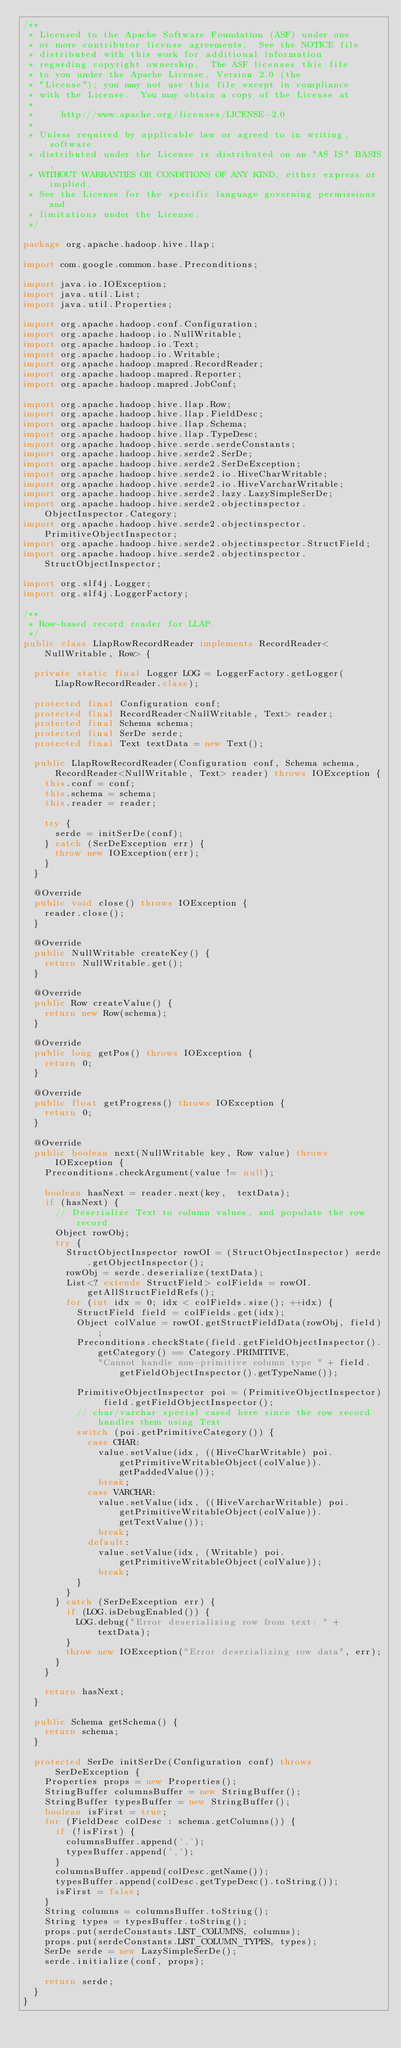<code> <loc_0><loc_0><loc_500><loc_500><_Java_>/**
 * Licensed to the Apache Software Foundation (ASF) under one
 * or more contributor license agreements.  See the NOTICE file
 * distributed with this work for additional information
 * regarding copyright ownership.  The ASF licenses this file
 * to you under the Apache License, Version 2.0 (the
 * "License"); you may not use this file except in compliance
 * with the License.  You may obtain a copy of the License at
 *
 *     http://www.apache.org/licenses/LICENSE-2.0
 *
 * Unless required by applicable law or agreed to in writing, software
 * distributed under the License is distributed on an "AS IS" BASIS,
 * WITHOUT WARRANTIES OR CONDITIONS OF ANY KIND, either express or implied.
 * See the License for the specific language governing permissions and
 * limitations under the License.
 */

package org.apache.hadoop.hive.llap;

import com.google.common.base.Preconditions;

import java.io.IOException;
import java.util.List;
import java.util.Properties;

import org.apache.hadoop.conf.Configuration;
import org.apache.hadoop.io.NullWritable;
import org.apache.hadoop.io.Text;
import org.apache.hadoop.io.Writable;
import org.apache.hadoop.mapred.RecordReader;
import org.apache.hadoop.mapred.Reporter;
import org.apache.hadoop.mapred.JobConf;

import org.apache.hadoop.hive.llap.Row;
import org.apache.hadoop.hive.llap.FieldDesc;
import org.apache.hadoop.hive.llap.Schema;
import org.apache.hadoop.hive.llap.TypeDesc;
import org.apache.hadoop.hive.serde.serdeConstants;
import org.apache.hadoop.hive.serde2.SerDe;
import org.apache.hadoop.hive.serde2.SerDeException;
import org.apache.hadoop.hive.serde2.io.HiveCharWritable;
import org.apache.hadoop.hive.serde2.io.HiveVarcharWritable;
import org.apache.hadoop.hive.serde2.lazy.LazySimpleSerDe;
import org.apache.hadoop.hive.serde2.objectinspector.ObjectInspector.Category;
import org.apache.hadoop.hive.serde2.objectinspector.PrimitiveObjectInspector;
import org.apache.hadoop.hive.serde2.objectinspector.StructField;
import org.apache.hadoop.hive.serde2.objectinspector.StructObjectInspector;

import org.slf4j.Logger;
import org.slf4j.LoggerFactory;

/**
 * Row-based record reader for LLAP.
 */
public class LlapRowRecordReader implements RecordReader<NullWritable, Row> {

  private static final Logger LOG = LoggerFactory.getLogger(LlapRowRecordReader.class);

  protected final Configuration conf;
  protected final RecordReader<NullWritable, Text> reader;
  protected final Schema schema;
  protected final SerDe serde;
  protected final Text textData = new Text();

  public LlapRowRecordReader(Configuration conf, Schema schema, RecordReader<NullWritable, Text> reader) throws IOException {
    this.conf = conf;
    this.schema = schema;
    this.reader = reader;

    try {
      serde = initSerDe(conf);
    } catch (SerDeException err) {
      throw new IOException(err);
    }
  }

  @Override
  public void close() throws IOException {
    reader.close();
  }

  @Override
  public NullWritable createKey() {
    return NullWritable.get();
  }

  @Override
  public Row createValue() {
    return new Row(schema);
  }

  @Override
  public long getPos() throws IOException {
    return 0;
  }

  @Override
  public float getProgress() throws IOException {
    return 0;
  }

  @Override
  public boolean next(NullWritable key, Row value) throws IOException {
    Preconditions.checkArgument(value != null);

    boolean hasNext = reader.next(key,  textData);
    if (hasNext) {
      // Deserialize Text to column values, and populate the row record
      Object rowObj;
      try {
        StructObjectInspector rowOI = (StructObjectInspector) serde.getObjectInspector();
        rowObj = serde.deserialize(textData);
        List<? extends StructField> colFields = rowOI.getAllStructFieldRefs();
        for (int idx = 0; idx < colFields.size(); ++idx) {
          StructField field = colFields.get(idx);
          Object colValue = rowOI.getStructFieldData(rowObj, field);
          Preconditions.checkState(field.getFieldObjectInspector().getCategory() == Category.PRIMITIVE,
              "Cannot handle non-primitive column type " + field.getFieldObjectInspector().getTypeName());

          PrimitiveObjectInspector poi = (PrimitiveObjectInspector) field.getFieldObjectInspector();
          // char/varchar special cased here since the row record handles them using Text
          switch (poi.getPrimitiveCategory()) {
            case CHAR:
              value.setValue(idx, ((HiveCharWritable) poi.getPrimitiveWritableObject(colValue)).getPaddedValue());
              break;
            case VARCHAR:
              value.setValue(idx, ((HiveVarcharWritable) poi.getPrimitiveWritableObject(colValue)).getTextValue());
              break;
            default:
              value.setValue(idx, (Writable) poi.getPrimitiveWritableObject(colValue));
              break;
          }
        }
      } catch (SerDeException err) {
        if (LOG.isDebugEnabled()) {
          LOG.debug("Error deserializing row from text: " + textData);
        }
        throw new IOException("Error deserializing row data", err);
      }
    }

    return hasNext;
  }

  public Schema getSchema() {
    return schema;
  }

  protected SerDe initSerDe(Configuration conf) throws SerDeException {
    Properties props = new Properties();
    StringBuffer columnsBuffer = new StringBuffer();
    StringBuffer typesBuffer = new StringBuffer();
    boolean isFirst = true;
    for (FieldDesc colDesc : schema.getColumns()) {
      if (!isFirst) {
        columnsBuffer.append(',');
        typesBuffer.append(',');
      }
      columnsBuffer.append(colDesc.getName());
      typesBuffer.append(colDesc.getTypeDesc().toString());
      isFirst = false;
    }
    String columns = columnsBuffer.toString();
    String types = typesBuffer.toString();
    props.put(serdeConstants.LIST_COLUMNS, columns);
    props.put(serdeConstants.LIST_COLUMN_TYPES, types);
    SerDe serde = new LazySimpleSerDe();
    serde.initialize(conf, props);

    return serde;
  }
}
</code> 